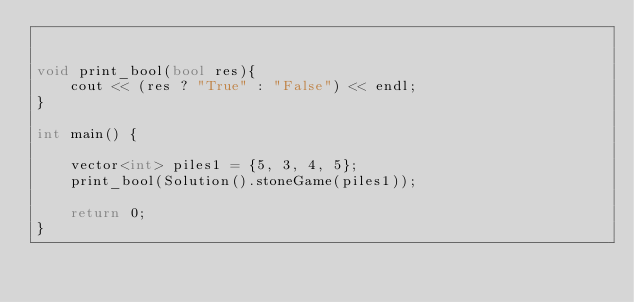<code> <loc_0><loc_0><loc_500><loc_500><_C++_>

void print_bool(bool res){
    cout << (res ? "True" : "False") << endl;
}

int main() {

    vector<int> piles1 = {5, 3, 4, 5};
    print_bool(Solution().stoneGame(piles1));

    return 0;
}</code> 